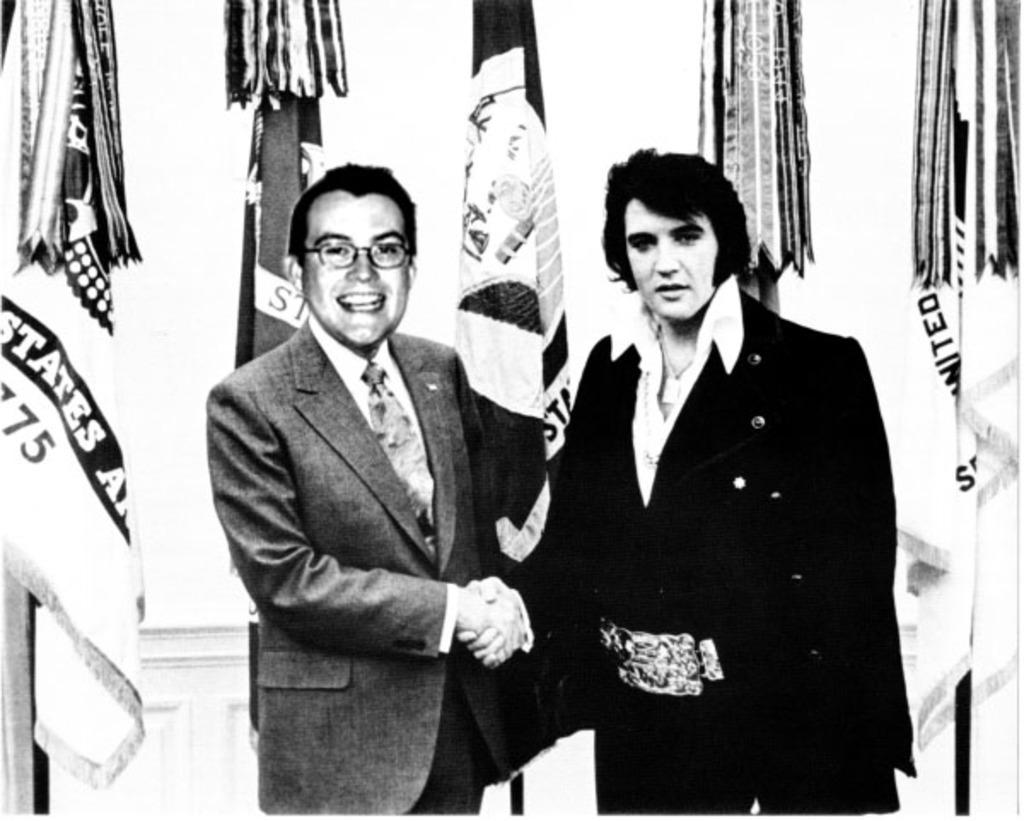What is the color scheme of the image? The image is black and white. What are the people in the image doing? The people in the image are standing and holding hands. Can you describe any specific features of one of the people? One person is wearing glasses. What can be seen in the background of the image? There are flags and a wall in the background. What is the taste of the stem in the image? There is no stem present in the image, so it is not possible to determine its taste. 